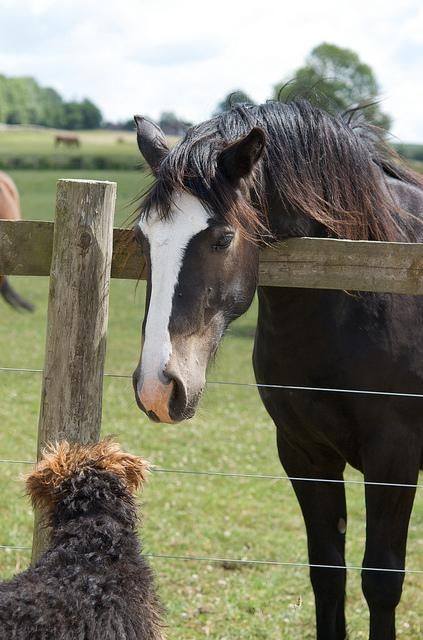This animal has a long what?

Choices:
A) stinger
B) face
C) wing
D) quill face 